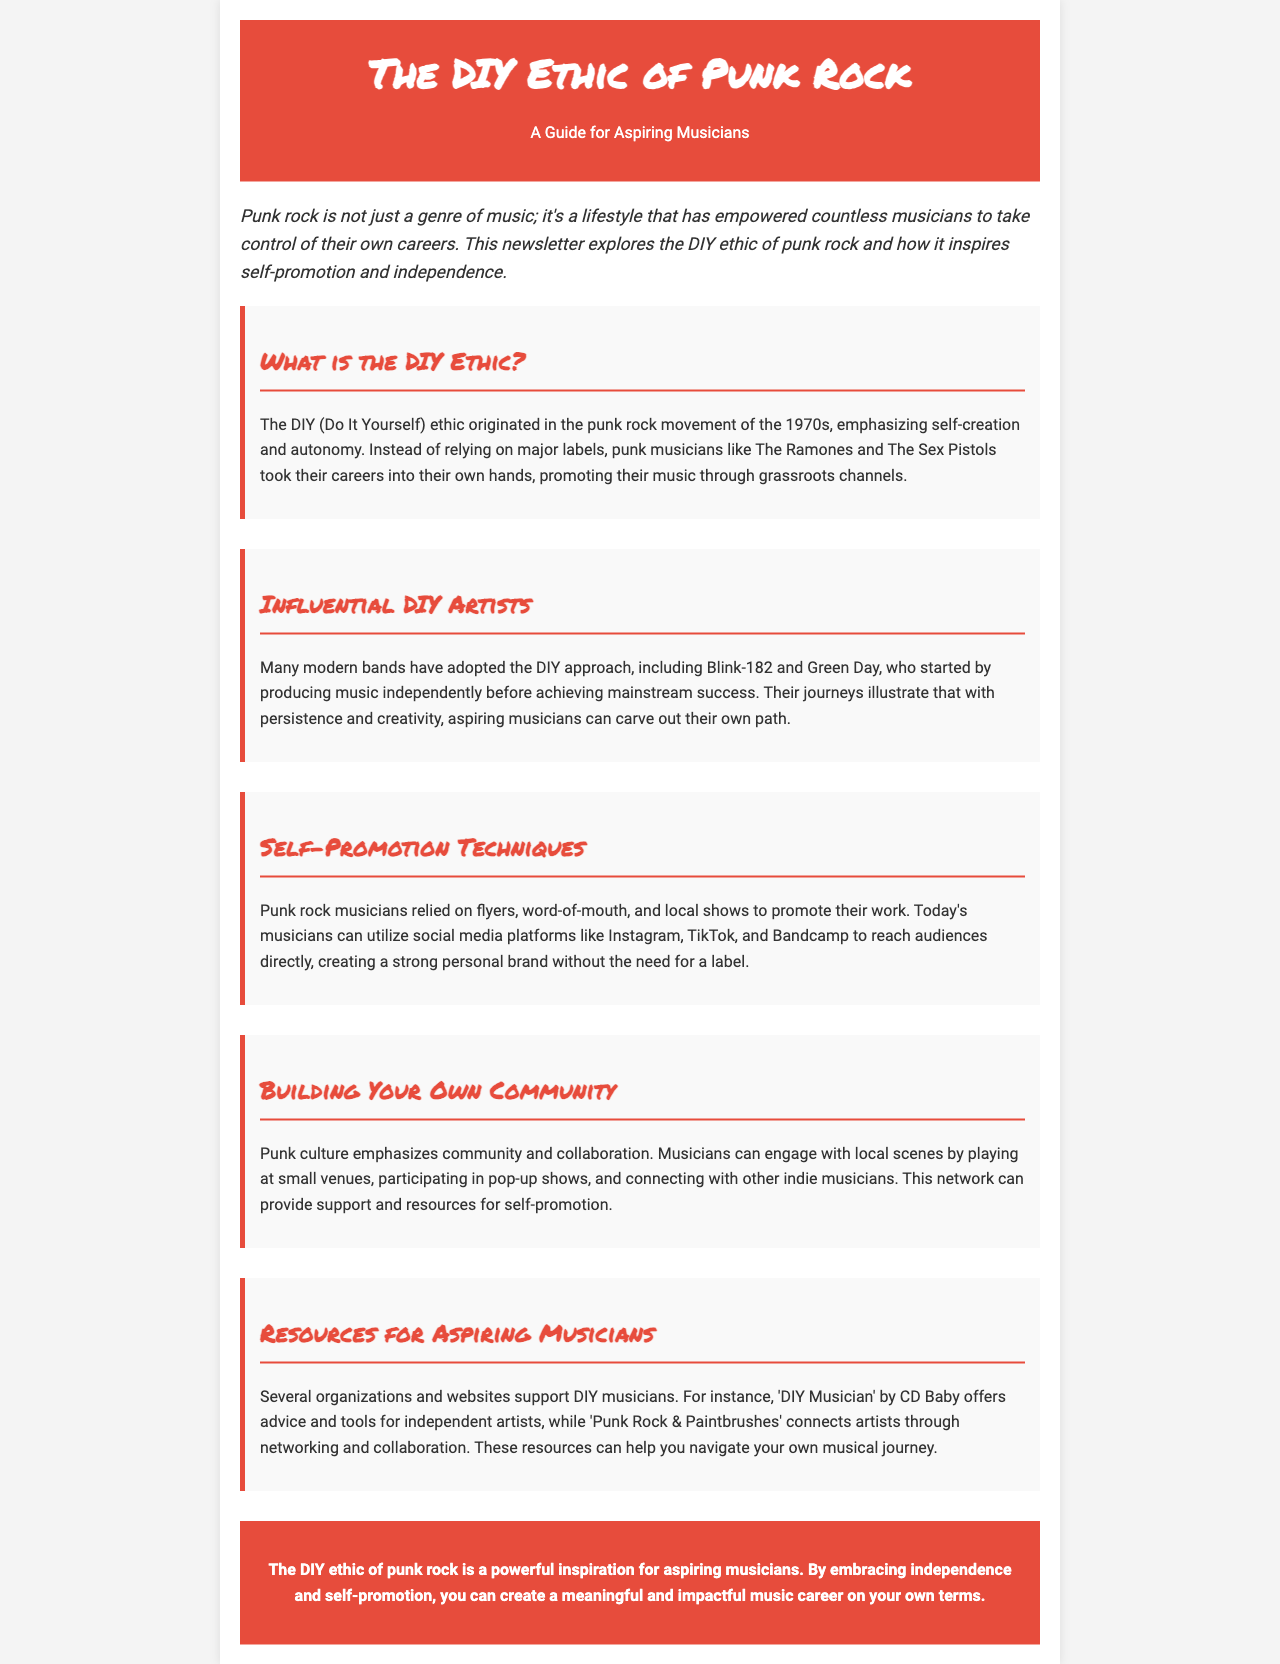What is the DIY ethic? The DIY ethic is a concept that emphasizes self-creation and autonomy, originating in the punk rock movement.
Answer: self-creation and autonomy Who are two influential punk rock bands mentioned? The document mentions influential bands that adopted the DIY approach, specifically The Ramones and The Sex Pistols.
Answer: The Ramones and The Sex Pistols What social media platforms can musicians use for self-promotion? The document lists social media platforms that musicians can utilize, such as Instagram and TikTok.
Answer: Instagram and TikTok What is a popular resource for DIY musicians? The document mentions 'DIY Musician' by CD Baby as a resource that supports independent artists.
Answer: DIY Musician by CD Baby How did punk rock musicians promote their work? The document explains that punk rock musicians relied on grassroots methods such as flyers and word-of-mouth.
Answer: flyers and word-of-mouth What is emphasized in punk culture according to the document? The document highlights the importance of community and collaboration in punk culture.
Answer: community and collaboration Which two modern bands are mentioned as having adopted the DIY approach? The document cites Blink-182 and Green Day as modern bands that started producing music independently.
Answer: Blink-182 and Green Day What tone is used in the introduction of the newsletter? The introduction of the newsletter uses an italicized font style to set its tone.
Answer: italicized font style 